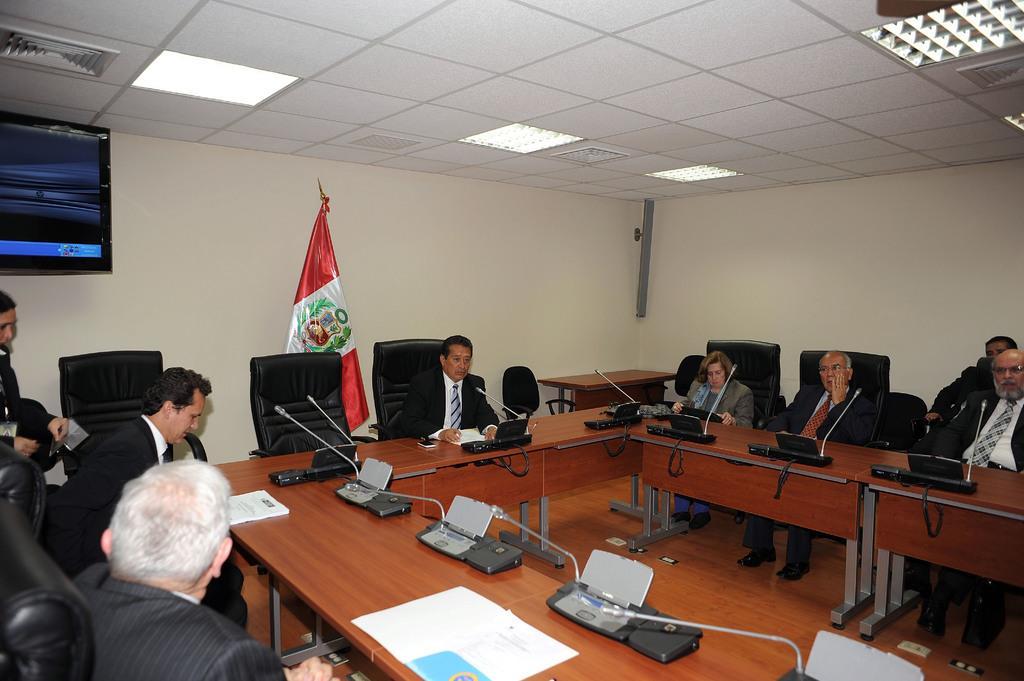Describe this image in one or two sentences. This picture is an inside view of a room. In the center of the image we can see the tables. On the tables we can see papers, books and some objects, mics. Beside the tables we can see some persons are sitting on a chair. In the background of the image we can see flat, screen, wall. At the top of the image we can see roof and lights. At the bottom of the image we can see the floor. 